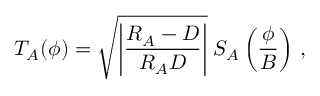<formula> <loc_0><loc_0><loc_500><loc_500>T _ { A } ( \boldsymbol \phi ) = \sqrt { \left | { \frac { R _ { A } - D } { R _ { A } D } } \right | } \, S _ { A } \left ( { \frac { \boldsymbol \phi } { B } } \right ) \, ,</formula> 